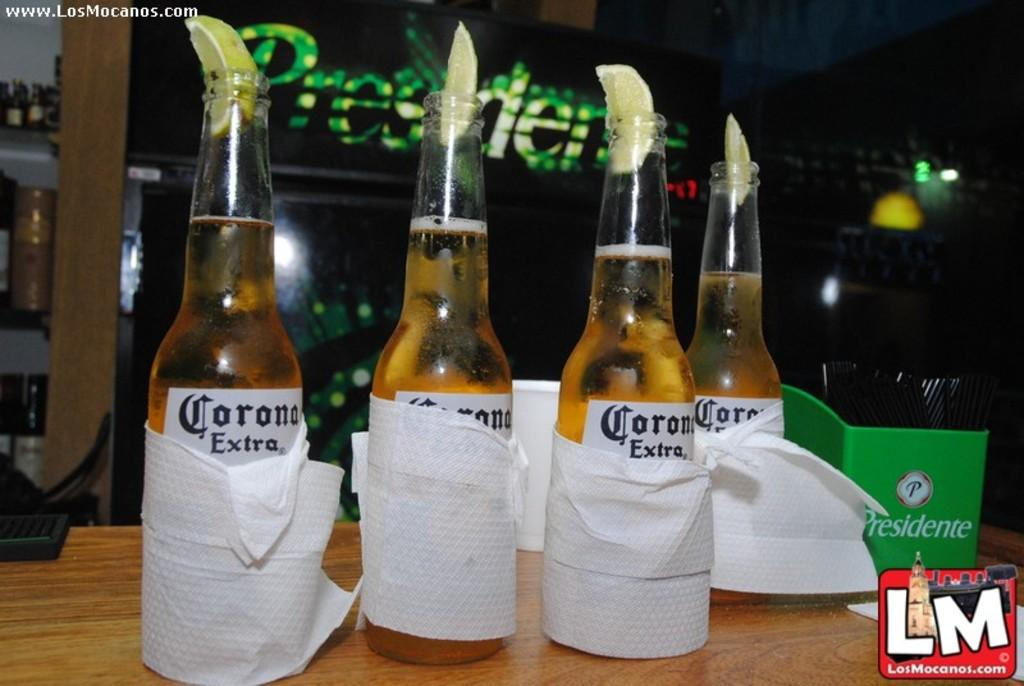Provide a one-sentence caption for the provided image. Four Coronas have limes stuffed in their tops. 